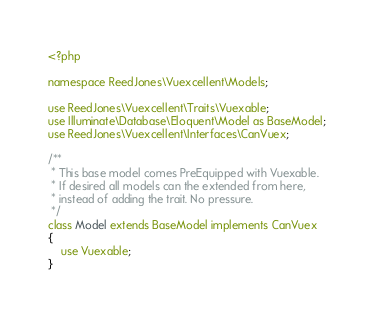Convert code to text. <code><loc_0><loc_0><loc_500><loc_500><_PHP_><?php

namespace ReedJones\Vuexcellent\Models;

use ReedJones\Vuexcellent\Traits\Vuexable;
use Illuminate\Database\Eloquent\Model as BaseModel;
use ReedJones\Vuexcellent\Interfaces\CanVuex;

/**
 * This base model comes PreEquipped with Vuexable.
 * If desired all models can the extended from here,
 * instead of adding the trait. No pressure.
 */
class Model extends BaseModel implements CanVuex
{
    use Vuexable;
}
</code> 